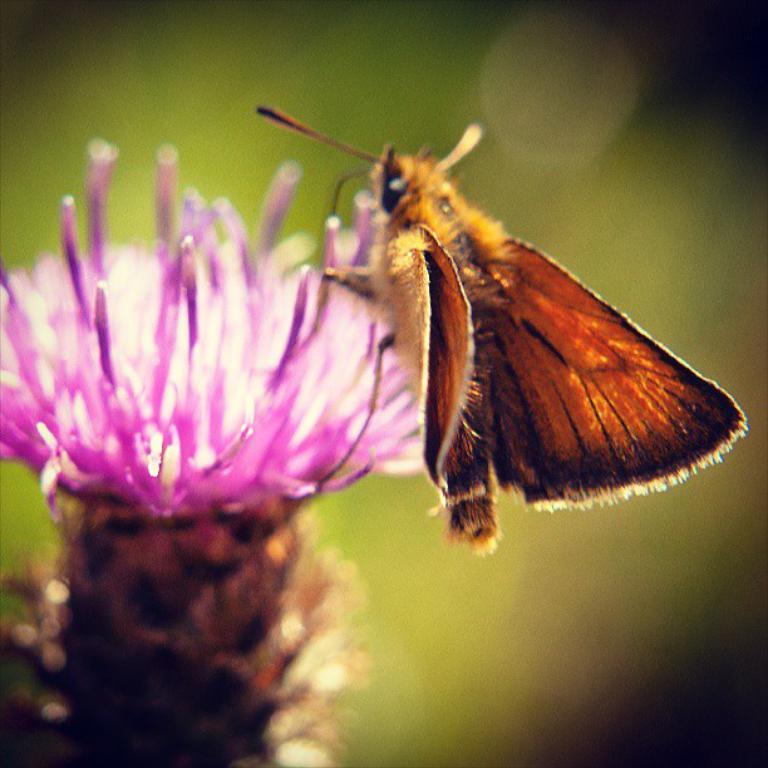Describe this image in one or two sentences. In this image I can see a flower and on it I can see an insect. I can also see this image is little bit blurry in the background. 